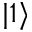Convert formula to latex. <formula><loc_0><loc_0><loc_500><loc_500>| 1 \rangle</formula> 